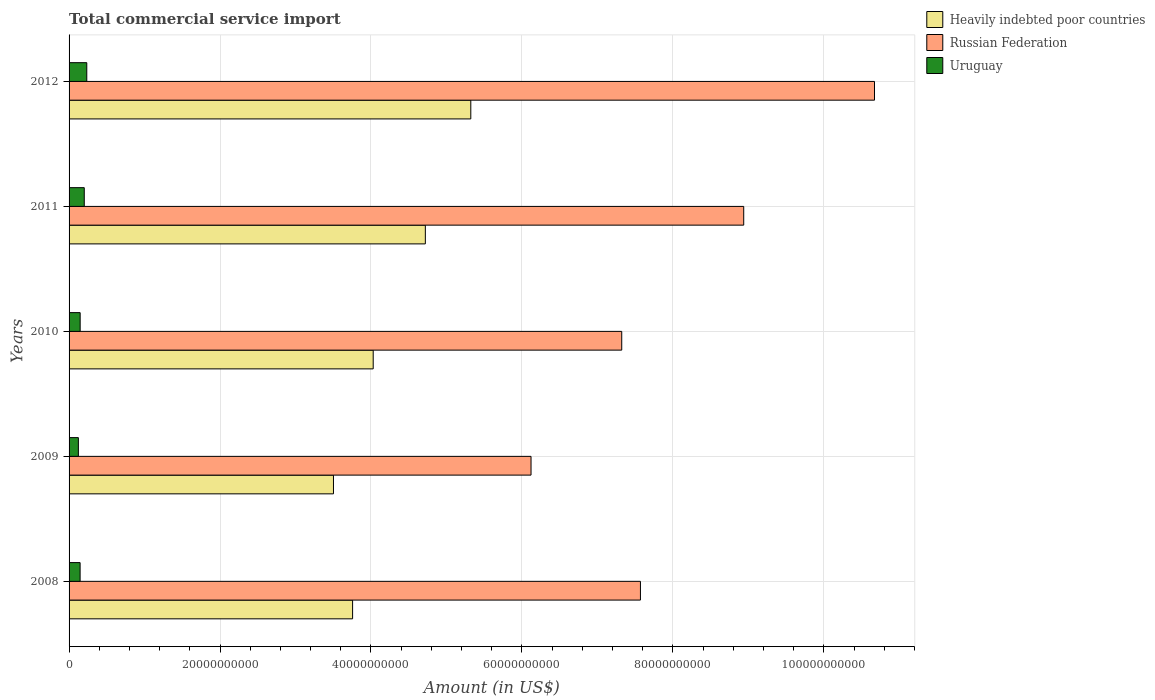Are the number of bars per tick equal to the number of legend labels?
Offer a very short reply. Yes. What is the total commercial service import in Uruguay in 2011?
Offer a very short reply. 2.01e+09. Across all years, what is the maximum total commercial service import in Heavily indebted poor countries?
Give a very brief answer. 5.32e+1. Across all years, what is the minimum total commercial service import in Uruguay?
Keep it short and to the point. 1.23e+09. In which year was the total commercial service import in Russian Federation maximum?
Provide a short and direct response. 2012. In which year was the total commercial service import in Uruguay minimum?
Ensure brevity in your answer.  2009. What is the total total commercial service import in Heavily indebted poor countries in the graph?
Provide a succinct answer. 2.13e+11. What is the difference between the total commercial service import in Heavily indebted poor countries in 2010 and that in 2011?
Offer a terse response. -6.91e+09. What is the difference between the total commercial service import in Heavily indebted poor countries in 2008 and the total commercial service import in Russian Federation in 2012?
Give a very brief answer. -6.92e+1. What is the average total commercial service import in Heavily indebted poor countries per year?
Offer a terse response. 4.27e+1. In the year 2009, what is the difference between the total commercial service import in Uruguay and total commercial service import in Russian Federation?
Provide a short and direct response. -6.00e+1. What is the ratio of the total commercial service import in Uruguay in 2009 to that in 2012?
Ensure brevity in your answer.  0.53. Is the total commercial service import in Heavily indebted poor countries in 2009 less than that in 2011?
Offer a terse response. Yes. Is the difference between the total commercial service import in Uruguay in 2009 and 2011 greater than the difference between the total commercial service import in Russian Federation in 2009 and 2011?
Provide a succinct answer. Yes. What is the difference between the highest and the second highest total commercial service import in Heavily indebted poor countries?
Offer a terse response. 6.02e+09. What is the difference between the highest and the lowest total commercial service import in Russian Federation?
Your response must be concise. 4.55e+1. In how many years, is the total commercial service import in Uruguay greater than the average total commercial service import in Uruguay taken over all years?
Keep it short and to the point. 2. Is the sum of the total commercial service import in Heavily indebted poor countries in 2009 and 2012 greater than the maximum total commercial service import in Russian Federation across all years?
Your response must be concise. No. What does the 1st bar from the top in 2010 represents?
Offer a very short reply. Uruguay. What does the 2nd bar from the bottom in 2009 represents?
Your response must be concise. Russian Federation. How many bars are there?
Make the answer very short. 15. Are all the bars in the graph horizontal?
Make the answer very short. Yes. What is the difference between two consecutive major ticks on the X-axis?
Your answer should be very brief. 2.00e+1. Does the graph contain any zero values?
Make the answer very short. No. Does the graph contain grids?
Make the answer very short. Yes. How many legend labels are there?
Make the answer very short. 3. How are the legend labels stacked?
Your response must be concise. Vertical. What is the title of the graph?
Your response must be concise. Total commercial service import. What is the label or title of the X-axis?
Provide a succinct answer. Amount (in US$). What is the Amount (in US$) in Heavily indebted poor countries in 2008?
Offer a terse response. 3.76e+1. What is the Amount (in US$) of Russian Federation in 2008?
Give a very brief answer. 7.57e+1. What is the Amount (in US$) of Uruguay in 2008?
Your answer should be very brief. 1.46e+09. What is the Amount (in US$) of Heavily indebted poor countries in 2009?
Provide a succinct answer. 3.50e+1. What is the Amount (in US$) of Russian Federation in 2009?
Provide a succinct answer. 6.12e+1. What is the Amount (in US$) in Uruguay in 2009?
Provide a succinct answer. 1.23e+09. What is the Amount (in US$) in Heavily indebted poor countries in 2010?
Make the answer very short. 4.03e+1. What is the Amount (in US$) of Russian Federation in 2010?
Make the answer very short. 7.32e+1. What is the Amount (in US$) of Uruguay in 2010?
Offer a terse response. 1.47e+09. What is the Amount (in US$) in Heavily indebted poor countries in 2011?
Your answer should be compact. 4.72e+1. What is the Amount (in US$) of Russian Federation in 2011?
Give a very brief answer. 8.94e+1. What is the Amount (in US$) in Uruguay in 2011?
Keep it short and to the point. 2.01e+09. What is the Amount (in US$) of Heavily indebted poor countries in 2012?
Keep it short and to the point. 5.32e+1. What is the Amount (in US$) in Russian Federation in 2012?
Provide a short and direct response. 1.07e+11. What is the Amount (in US$) in Uruguay in 2012?
Ensure brevity in your answer.  2.35e+09. Across all years, what is the maximum Amount (in US$) in Heavily indebted poor countries?
Ensure brevity in your answer.  5.32e+1. Across all years, what is the maximum Amount (in US$) of Russian Federation?
Provide a succinct answer. 1.07e+11. Across all years, what is the maximum Amount (in US$) in Uruguay?
Provide a succinct answer. 2.35e+09. Across all years, what is the minimum Amount (in US$) of Heavily indebted poor countries?
Keep it short and to the point. 3.50e+1. Across all years, what is the minimum Amount (in US$) of Russian Federation?
Offer a terse response. 6.12e+1. Across all years, what is the minimum Amount (in US$) of Uruguay?
Offer a terse response. 1.23e+09. What is the total Amount (in US$) of Heavily indebted poor countries in the graph?
Ensure brevity in your answer.  2.13e+11. What is the total Amount (in US$) in Russian Federation in the graph?
Offer a terse response. 4.06e+11. What is the total Amount (in US$) of Uruguay in the graph?
Offer a terse response. 8.53e+09. What is the difference between the Amount (in US$) in Heavily indebted poor countries in 2008 and that in 2009?
Keep it short and to the point. 2.54e+09. What is the difference between the Amount (in US$) in Russian Federation in 2008 and that in 2009?
Your response must be concise. 1.45e+1. What is the difference between the Amount (in US$) in Uruguay in 2008 and that in 2009?
Your answer should be compact. 2.29e+08. What is the difference between the Amount (in US$) in Heavily indebted poor countries in 2008 and that in 2010?
Provide a succinct answer. -2.73e+09. What is the difference between the Amount (in US$) of Russian Federation in 2008 and that in 2010?
Your answer should be very brief. 2.48e+09. What is the difference between the Amount (in US$) in Uruguay in 2008 and that in 2010?
Your answer should be compact. -7.59e+06. What is the difference between the Amount (in US$) of Heavily indebted poor countries in 2008 and that in 2011?
Your response must be concise. -9.64e+09. What is the difference between the Amount (in US$) of Russian Federation in 2008 and that in 2011?
Provide a succinct answer. -1.37e+1. What is the difference between the Amount (in US$) in Uruguay in 2008 and that in 2011?
Make the answer very short. -5.52e+08. What is the difference between the Amount (in US$) of Heavily indebted poor countries in 2008 and that in 2012?
Offer a terse response. -1.57e+1. What is the difference between the Amount (in US$) of Russian Federation in 2008 and that in 2012?
Your response must be concise. -3.10e+1. What is the difference between the Amount (in US$) of Uruguay in 2008 and that in 2012?
Your answer should be compact. -8.85e+08. What is the difference between the Amount (in US$) of Heavily indebted poor countries in 2009 and that in 2010?
Your answer should be very brief. -5.27e+09. What is the difference between the Amount (in US$) in Russian Federation in 2009 and that in 2010?
Provide a short and direct response. -1.20e+1. What is the difference between the Amount (in US$) of Uruguay in 2009 and that in 2010?
Provide a short and direct response. -2.36e+08. What is the difference between the Amount (in US$) in Heavily indebted poor countries in 2009 and that in 2011?
Keep it short and to the point. -1.22e+1. What is the difference between the Amount (in US$) of Russian Federation in 2009 and that in 2011?
Keep it short and to the point. -2.82e+1. What is the difference between the Amount (in US$) in Uruguay in 2009 and that in 2011?
Offer a very short reply. -7.80e+08. What is the difference between the Amount (in US$) of Heavily indebted poor countries in 2009 and that in 2012?
Provide a succinct answer. -1.82e+1. What is the difference between the Amount (in US$) of Russian Federation in 2009 and that in 2012?
Your answer should be compact. -4.55e+1. What is the difference between the Amount (in US$) in Uruguay in 2009 and that in 2012?
Your answer should be very brief. -1.11e+09. What is the difference between the Amount (in US$) of Heavily indebted poor countries in 2010 and that in 2011?
Offer a very short reply. -6.91e+09. What is the difference between the Amount (in US$) of Russian Federation in 2010 and that in 2011?
Make the answer very short. -1.62e+1. What is the difference between the Amount (in US$) of Uruguay in 2010 and that in 2011?
Offer a terse response. -5.44e+08. What is the difference between the Amount (in US$) in Heavily indebted poor countries in 2010 and that in 2012?
Make the answer very short. -1.29e+1. What is the difference between the Amount (in US$) in Russian Federation in 2010 and that in 2012?
Offer a terse response. -3.35e+1. What is the difference between the Amount (in US$) in Uruguay in 2010 and that in 2012?
Your answer should be compact. -8.77e+08. What is the difference between the Amount (in US$) in Heavily indebted poor countries in 2011 and that in 2012?
Give a very brief answer. -6.02e+09. What is the difference between the Amount (in US$) of Russian Federation in 2011 and that in 2012?
Offer a terse response. -1.73e+1. What is the difference between the Amount (in US$) of Uruguay in 2011 and that in 2012?
Give a very brief answer. -3.33e+08. What is the difference between the Amount (in US$) in Heavily indebted poor countries in 2008 and the Amount (in US$) in Russian Federation in 2009?
Offer a terse response. -2.36e+1. What is the difference between the Amount (in US$) in Heavily indebted poor countries in 2008 and the Amount (in US$) in Uruguay in 2009?
Offer a very short reply. 3.63e+1. What is the difference between the Amount (in US$) in Russian Federation in 2008 and the Amount (in US$) in Uruguay in 2009?
Offer a very short reply. 7.45e+1. What is the difference between the Amount (in US$) in Heavily indebted poor countries in 2008 and the Amount (in US$) in Russian Federation in 2010?
Keep it short and to the point. -3.57e+1. What is the difference between the Amount (in US$) of Heavily indebted poor countries in 2008 and the Amount (in US$) of Uruguay in 2010?
Give a very brief answer. 3.61e+1. What is the difference between the Amount (in US$) in Russian Federation in 2008 and the Amount (in US$) in Uruguay in 2010?
Provide a succinct answer. 7.42e+1. What is the difference between the Amount (in US$) of Heavily indebted poor countries in 2008 and the Amount (in US$) of Russian Federation in 2011?
Provide a short and direct response. -5.18e+1. What is the difference between the Amount (in US$) of Heavily indebted poor countries in 2008 and the Amount (in US$) of Uruguay in 2011?
Your answer should be compact. 3.56e+1. What is the difference between the Amount (in US$) in Russian Federation in 2008 and the Amount (in US$) in Uruguay in 2011?
Make the answer very short. 7.37e+1. What is the difference between the Amount (in US$) in Heavily indebted poor countries in 2008 and the Amount (in US$) in Russian Federation in 2012?
Provide a succinct answer. -6.92e+1. What is the difference between the Amount (in US$) in Heavily indebted poor countries in 2008 and the Amount (in US$) in Uruguay in 2012?
Provide a succinct answer. 3.52e+1. What is the difference between the Amount (in US$) in Russian Federation in 2008 and the Amount (in US$) in Uruguay in 2012?
Provide a succinct answer. 7.34e+1. What is the difference between the Amount (in US$) of Heavily indebted poor countries in 2009 and the Amount (in US$) of Russian Federation in 2010?
Your answer should be compact. -3.82e+1. What is the difference between the Amount (in US$) of Heavily indebted poor countries in 2009 and the Amount (in US$) of Uruguay in 2010?
Provide a succinct answer. 3.36e+1. What is the difference between the Amount (in US$) in Russian Federation in 2009 and the Amount (in US$) in Uruguay in 2010?
Provide a succinct answer. 5.97e+1. What is the difference between the Amount (in US$) in Heavily indebted poor countries in 2009 and the Amount (in US$) in Russian Federation in 2011?
Your answer should be very brief. -5.44e+1. What is the difference between the Amount (in US$) in Heavily indebted poor countries in 2009 and the Amount (in US$) in Uruguay in 2011?
Make the answer very short. 3.30e+1. What is the difference between the Amount (in US$) of Russian Federation in 2009 and the Amount (in US$) of Uruguay in 2011?
Your response must be concise. 5.92e+1. What is the difference between the Amount (in US$) of Heavily indebted poor countries in 2009 and the Amount (in US$) of Russian Federation in 2012?
Give a very brief answer. -7.17e+1. What is the difference between the Amount (in US$) of Heavily indebted poor countries in 2009 and the Amount (in US$) of Uruguay in 2012?
Offer a terse response. 3.27e+1. What is the difference between the Amount (in US$) of Russian Federation in 2009 and the Amount (in US$) of Uruguay in 2012?
Make the answer very short. 5.89e+1. What is the difference between the Amount (in US$) in Heavily indebted poor countries in 2010 and the Amount (in US$) in Russian Federation in 2011?
Your answer should be very brief. -4.91e+1. What is the difference between the Amount (in US$) of Heavily indebted poor countries in 2010 and the Amount (in US$) of Uruguay in 2011?
Your answer should be very brief. 3.83e+1. What is the difference between the Amount (in US$) of Russian Federation in 2010 and the Amount (in US$) of Uruguay in 2011?
Offer a very short reply. 7.12e+1. What is the difference between the Amount (in US$) in Heavily indebted poor countries in 2010 and the Amount (in US$) in Russian Federation in 2012?
Provide a succinct answer. -6.64e+1. What is the difference between the Amount (in US$) in Heavily indebted poor countries in 2010 and the Amount (in US$) in Uruguay in 2012?
Give a very brief answer. 3.80e+1. What is the difference between the Amount (in US$) in Russian Federation in 2010 and the Amount (in US$) in Uruguay in 2012?
Make the answer very short. 7.09e+1. What is the difference between the Amount (in US$) in Heavily indebted poor countries in 2011 and the Amount (in US$) in Russian Federation in 2012?
Your response must be concise. -5.95e+1. What is the difference between the Amount (in US$) of Heavily indebted poor countries in 2011 and the Amount (in US$) of Uruguay in 2012?
Your answer should be compact. 4.49e+1. What is the difference between the Amount (in US$) of Russian Federation in 2011 and the Amount (in US$) of Uruguay in 2012?
Your answer should be compact. 8.70e+1. What is the average Amount (in US$) of Heavily indebted poor countries per year?
Give a very brief answer. 4.27e+1. What is the average Amount (in US$) of Russian Federation per year?
Make the answer very short. 8.12e+1. What is the average Amount (in US$) of Uruguay per year?
Provide a succinct answer. 1.71e+09. In the year 2008, what is the difference between the Amount (in US$) in Heavily indebted poor countries and Amount (in US$) in Russian Federation?
Keep it short and to the point. -3.81e+1. In the year 2008, what is the difference between the Amount (in US$) in Heavily indebted poor countries and Amount (in US$) in Uruguay?
Ensure brevity in your answer.  3.61e+1. In the year 2008, what is the difference between the Amount (in US$) in Russian Federation and Amount (in US$) in Uruguay?
Provide a succinct answer. 7.42e+1. In the year 2009, what is the difference between the Amount (in US$) in Heavily indebted poor countries and Amount (in US$) in Russian Federation?
Give a very brief answer. -2.62e+1. In the year 2009, what is the difference between the Amount (in US$) of Heavily indebted poor countries and Amount (in US$) of Uruguay?
Give a very brief answer. 3.38e+1. In the year 2009, what is the difference between the Amount (in US$) in Russian Federation and Amount (in US$) in Uruguay?
Ensure brevity in your answer.  6.00e+1. In the year 2010, what is the difference between the Amount (in US$) in Heavily indebted poor countries and Amount (in US$) in Russian Federation?
Give a very brief answer. -3.29e+1. In the year 2010, what is the difference between the Amount (in US$) in Heavily indebted poor countries and Amount (in US$) in Uruguay?
Ensure brevity in your answer.  3.88e+1. In the year 2010, what is the difference between the Amount (in US$) in Russian Federation and Amount (in US$) in Uruguay?
Keep it short and to the point. 7.18e+1. In the year 2011, what is the difference between the Amount (in US$) in Heavily indebted poor countries and Amount (in US$) in Russian Federation?
Make the answer very short. -4.22e+1. In the year 2011, what is the difference between the Amount (in US$) of Heavily indebted poor countries and Amount (in US$) of Uruguay?
Ensure brevity in your answer.  4.52e+1. In the year 2011, what is the difference between the Amount (in US$) in Russian Federation and Amount (in US$) in Uruguay?
Your response must be concise. 8.74e+1. In the year 2012, what is the difference between the Amount (in US$) in Heavily indebted poor countries and Amount (in US$) in Russian Federation?
Your answer should be very brief. -5.35e+1. In the year 2012, what is the difference between the Amount (in US$) of Heavily indebted poor countries and Amount (in US$) of Uruguay?
Your answer should be very brief. 5.09e+1. In the year 2012, what is the difference between the Amount (in US$) in Russian Federation and Amount (in US$) in Uruguay?
Provide a short and direct response. 1.04e+11. What is the ratio of the Amount (in US$) of Heavily indebted poor countries in 2008 to that in 2009?
Provide a succinct answer. 1.07. What is the ratio of the Amount (in US$) of Russian Federation in 2008 to that in 2009?
Provide a succinct answer. 1.24. What is the ratio of the Amount (in US$) in Uruguay in 2008 to that in 2009?
Make the answer very short. 1.19. What is the ratio of the Amount (in US$) in Heavily indebted poor countries in 2008 to that in 2010?
Your response must be concise. 0.93. What is the ratio of the Amount (in US$) in Russian Federation in 2008 to that in 2010?
Keep it short and to the point. 1.03. What is the ratio of the Amount (in US$) of Uruguay in 2008 to that in 2010?
Provide a succinct answer. 0.99. What is the ratio of the Amount (in US$) of Heavily indebted poor countries in 2008 to that in 2011?
Your response must be concise. 0.8. What is the ratio of the Amount (in US$) in Russian Federation in 2008 to that in 2011?
Ensure brevity in your answer.  0.85. What is the ratio of the Amount (in US$) in Uruguay in 2008 to that in 2011?
Your response must be concise. 0.73. What is the ratio of the Amount (in US$) in Heavily indebted poor countries in 2008 to that in 2012?
Offer a terse response. 0.71. What is the ratio of the Amount (in US$) of Russian Federation in 2008 to that in 2012?
Your answer should be very brief. 0.71. What is the ratio of the Amount (in US$) of Uruguay in 2008 to that in 2012?
Your answer should be compact. 0.62. What is the ratio of the Amount (in US$) of Heavily indebted poor countries in 2009 to that in 2010?
Your answer should be very brief. 0.87. What is the ratio of the Amount (in US$) of Russian Federation in 2009 to that in 2010?
Your response must be concise. 0.84. What is the ratio of the Amount (in US$) of Uruguay in 2009 to that in 2010?
Your answer should be very brief. 0.84. What is the ratio of the Amount (in US$) in Heavily indebted poor countries in 2009 to that in 2011?
Your answer should be compact. 0.74. What is the ratio of the Amount (in US$) of Russian Federation in 2009 to that in 2011?
Ensure brevity in your answer.  0.68. What is the ratio of the Amount (in US$) in Uruguay in 2009 to that in 2011?
Offer a very short reply. 0.61. What is the ratio of the Amount (in US$) in Heavily indebted poor countries in 2009 to that in 2012?
Provide a short and direct response. 0.66. What is the ratio of the Amount (in US$) of Russian Federation in 2009 to that in 2012?
Make the answer very short. 0.57. What is the ratio of the Amount (in US$) of Uruguay in 2009 to that in 2012?
Provide a succinct answer. 0.53. What is the ratio of the Amount (in US$) of Heavily indebted poor countries in 2010 to that in 2011?
Your answer should be very brief. 0.85. What is the ratio of the Amount (in US$) in Russian Federation in 2010 to that in 2011?
Offer a terse response. 0.82. What is the ratio of the Amount (in US$) in Uruguay in 2010 to that in 2011?
Keep it short and to the point. 0.73. What is the ratio of the Amount (in US$) of Heavily indebted poor countries in 2010 to that in 2012?
Offer a very short reply. 0.76. What is the ratio of the Amount (in US$) in Russian Federation in 2010 to that in 2012?
Your answer should be compact. 0.69. What is the ratio of the Amount (in US$) in Uruguay in 2010 to that in 2012?
Give a very brief answer. 0.63. What is the ratio of the Amount (in US$) of Heavily indebted poor countries in 2011 to that in 2012?
Offer a terse response. 0.89. What is the ratio of the Amount (in US$) in Russian Federation in 2011 to that in 2012?
Your response must be concise. 0.84. What is the ratio of the Amount (in US$) of Uruguay in 2011 to that in 2012?
Make the answer very short. 0.86. What is the difference between the highest and the second highest Amount (in US$) of Heavily indebted poor countries?
Make the answer very short. 6.02e+09. What is the difference between the highest and the second highest Amount (in US$) of Russian Federation?
Your response must be concise. 1.73e+1. What is the difference between the highest and the second highest Amount (in US$) of Uruguay?
Offer a terse response. 3.33e+08. What is the difference between the highest and the lowest Amount (in US$) in Heavily indebted poor countries?
Your response must be concise. 1.82e+1. What is the difference between the highest and the lowest Amount (in US$) of Russian Federation?
Ensure brevity in your answer.  4.55e+1. What is the difference between the highest and the lowest Amount (in US$) in Uruguay?
Your answer should be compact. 1.11e+09. 